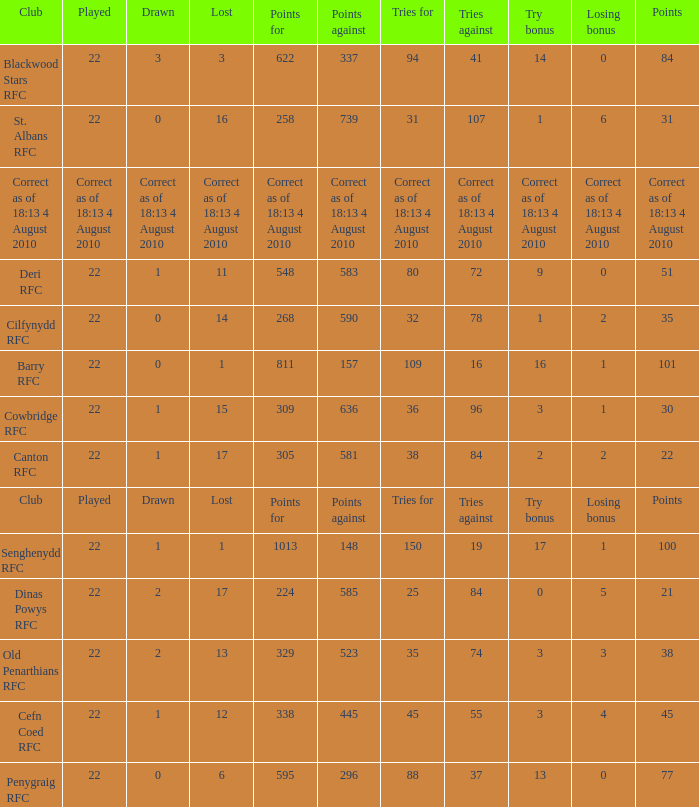What is the lost when the club was Barry RFC? 1.0. 